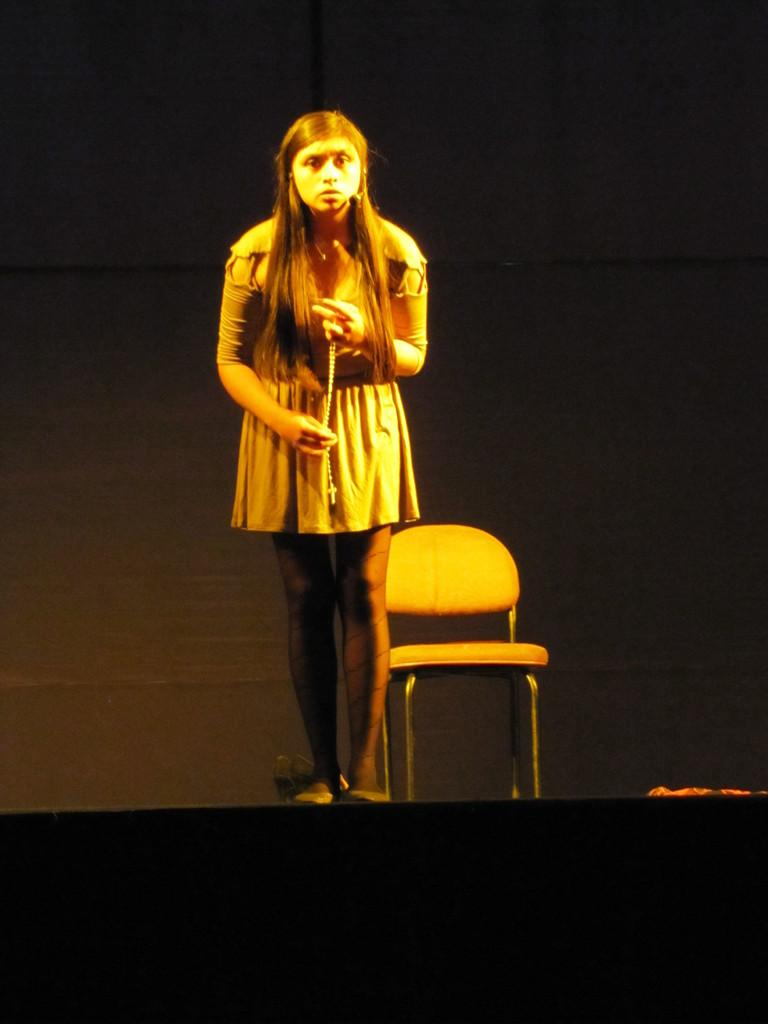Who is the main subject in the image? There is a woman in the image. What is the woman doing in the image? The woman is standing. What is the woman holding in the image? The woman is holding an object. What piece of furniture is present in the image? There is a chair in the image. How would you describe the lighting in the image? The background of the image is dark. What does the son say when he sees the surprise in the image? There is no son or surprise present in the image. 